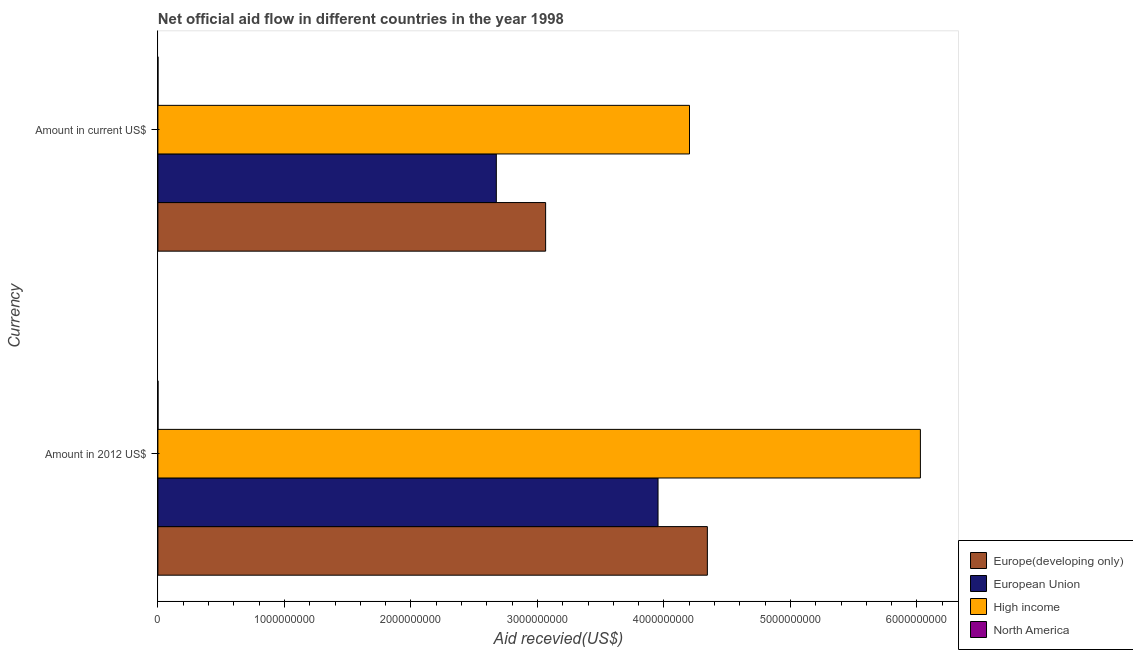How many groups of bars are there?
Make the answer very short. 2. Are the number of bars on each tick of the Y-axis equal?
Your response must be concise. Yes. How many bars are there on the 2nd tick from the top?
Ensure brevity in your answer.  4. How many bars are there on the 1st tick from the bottom?
Offer a very short reply. 4. What is the label of the 1st group of bars from the top?
Your answer should be very brief. Amount in current US$. What is the amount of aid received(expressed in 2012 us$) in North America?
Your answer should be compact. 7.40e+05. Across all countries, what is the maximum amount of aid received(expressed in us$)?
Provide a short and direct response. 4.20e+09. Across all countries, what is the minimum amount of aid received(expressed in 2012 us$)?
Your answer should be compact. 7.40e+05. In which country was the amount of aid received(expressed in us$) minimum?
Offer a very short reply. North America. What is the total amount of aid received(expressed in us$) in the graph?
Provide a short and direct response. 9.94e+09. What is the difference between the amount of aid received(expressed in 2012 us$) in North America and that in High income?
Provide a short and direct response. -6.03e+09. What is the difference between the amount of aid received(expressed in us$) in European Union and the amount of aid received(expressed in 2012 us$) in Europe(developing only)?
Make the answer very short. -1.67e+09. What is the average amount of aid received(expressed in us$) per country?
Provide a short and direct response. 2.49e+09. What is the difference between the amount of aid received(expressed in 2012 us$) and amount of aid received(expressed in us$) in European Union?
Provide a succinct answer. 1.28e+09. In how many countries, is the amount of aid received(expressed in us$) greater than 2200000000 US$?
Offer a very short reply. 3. What is the ratio of the amount of aid received(expressed in 2012 us$) in Europe(developing only) to that in European Union?
Make the answer very short. 1.1. Is the amount of aid received(expressed in 2012 us$) in High income less than that in Europe(developing only)?
Provide a short and direct response. No. In how many countries, is the amount of aid received(expressed in 2012 us$) greater than the average amount of aid received(expressed in 2012 us$) taken over all countries?
Your answer should be compact. 3. What does the 4th bar from the top in Amount in current US$ represents?
Your answer should be compact. Europe(developing only). What does the 3rd bar from the bottom in Amount in current US$ represents?
Make the answer very short. High income. Are all the bars in the graph horizontal?
Provide a succinct answer. Yes. How many countries are there in the graph?
Provide a succinct answer. 4. What is the difference between two consecutive major ticks on the X-axis?
Provide a succinct answer. 1.00e+09. Are the values on the major ticks of X-axis written in scientific E-notation?
Your answer should be compact. No. How are the legend labels stacked?
Ensure brevity in your answer.  Vertical. What is the title of the graph?
Make the answer very short. Net official aid flow in different countries in the year 1998. Does "Antigua and Barbuda" appear as one of the legend labels in the graph?
Your answer should be compact. No. What is the label or title of the X-axis?
Ensure brevity in your answer.  Aid recevied(US$). What is the label or title of the Y-axis?
Provide a succinct answer. Currency. What is the Aid recevied(US$) in Europe(developing only) in Amount in 2012 US$?
Give a very brief answer. 4.34e+09. What is the Aid recevied(US$) of European Union in Amount in 2012 US$?
Provide a succinct answer. 3.95e+09. What is the Aid recevied(US$) in High income in Amount in 2012 US$?
Provide a succinct answer. 6.03e+09. What is the Aid recevied(US$) in North America in Amount in 2012 US$?
Offer a terse response. 7.40e+05. What is the Aid recevied(US$) of Europe(developing only) in Amount in current US$?
Ensure brevity in your answer.  3.06e+09. What is the Aid recevied(US$) in European Union in Amount in current US$?
Keep it short and to the point. 2.68e+09. What is the Aid recevied(US$) in High income in Amount in current US$?
Your answer should be compact. 4.20e+09. What is the Aid recevied(US$) of North America in Amount in current US$?
Ensure brevity in your answer.  5.50e+05. Across all Currency, what is the maximum Aid recevied(US$) of Europe(developing only)?
Your answer should be compact. 4.34e+09. Across all Currency, what is the maximum Aid recevied(US$) of European Union?
Provide a succinct answer. 3.95e+09. Across all Currency, what is the maximum Aid recevied(US$) of High income?
Your answer should be very brief. 6.03e+09. Across all Currency, what is the maximum Aid recevied(US$) of North America?
Offer a terse response. 7.40e+05. Across all Currency, what is the minimum Aid recevied(US$) of Europe(developing only)?
Your response must be concise. 3.06e+09. Across all Currency, what is the minimum Aid recevied(US$) of European Union?
Ensure brevity in your answer.  2.68e+09. Across all Currency, what is the minimum Aid recevied(US$) of High income?
Keep it short and to the point. 4.20e+09. Across all Currency, what is the minimum Aid recevied(US$) in North America?
Keep it short and to the point. 5.50e+05. What is the total Aid recevied(US$) of Europe(developing only) in the graph?
Your answer should be very brief. 7.41e+09. What is the total Aid recevied(US$) in European Union in the graph?
Keep it short and to the point. 6.63e+09. What is the total Aid recevied(US$) of High income in the graph?
Offer a very short reply. 1.02e+1. What is the total Aid recevied(US$) of North America in the graph?
Provide a succinct answer. 1.29e+06. What is the difference between the Aid recevied(US$) of Europe(developing only) in Amount in 2012 US$ and that in Amount in current US$?
Your answer should be very brief. 1.28e+09. What is the difference between the Aid recevied(US$) in European Union in Amount in 2012 US$ and that in Amount in current US$?
Ensure brevity in your answer.  1.28e+09. What is the difference between the Aid recevied(US$) in High income in Amount in 2012 US$ and that in Amount in current US$?
Offer a very short reply. 1.83e+09. What is the difference between the Aid recevied(US$) in Europe(developing only) in Amount in 2012 US$ and the Aid recevied(US$) in European Union in Amount in current US$?
Your answer should be very brief. 1.67e+09. What is the difference between the Aid recevied(US$) in Europe(developing only) in Amount in 2012 US$ and the Aid recevied(US$) in High income in Amount in current US$?
Ensure brevity in your answer.  1.41e+08. What is the difference between the Aid recevied(US$) of Europe(developing only) in Amount in 2012 US$ and the Aid recevied(US$) of North America in Amount in current US$?
Make the answer very short. 4.34e+09. What is the difference between the Aid recevied(US$) of European Union in Amount in 2012 US$ and the Aid recevied(US$) of High income in Amount in current US$?
Offer a terse response. -2.49e+08. What is the difference between the Aid recevied(US$) of European Union in Amount in 2012 US$ and the Aid recevied(US$) of North America in Amount in current US$?
Offer a terse response. 3.95e+09. What is the difference between the Aid recevied(US$) in High income in Amount in 2012 US$ and the Aid recevied(US$) in North America in Amount in current US$?
Ensure brevity in your answer.  6.03e+09. What is the average Aid recevied(US$) of Europe(developing only) per Currency?
Ensure brevity in your answer.  3.70e+09. What is the average Aid recevied(US$) in European Union per Currency?
Offer a terse response. 3.31e+09. What is the average Aid recevied(US$) of High income per Currency?
Ensure brevity in your answer.  5.11e+09. What is the average Aid recevied(US$) in North America per Currency?
Offer a very short reply. 6.45e+05. What is the difference between the Aid recevied(US$) in Europe(developing only) and Aid recevied(US$) in European Union in Amount in 2012 US$?
Offer a very short reply. 3.90e+08. What is the difference between the Aid recevied(US$) in Europe(developing only) and Aid recevied(US$) in High income in Amount in 2012 US$?
Provide a succinct answer. -1.68e+09. What is the difference between the Aid recevied(US$) of Europe(developing only) and Aid recevied(US$) of North America in Amount in 2012 US$?
Keep it short and to the point. 4.34e+09. What is the difference between the Aid recevied(US$) in European Union and Aid recevied(US$) in High income in Amount in 2012 US$?
Keep it short and to the point. -2.07e+09. What is the difference between the Aid recevied(US$) in European Union and Aid recevied(US$) in North America in Amount in 2012 US$?
Keep it short and to the point. 3.95e+09. What is the difference between the Aid recevied(US$) in High income and Aid recevied(US$) in North America in Amount in 2012 US$?
Give a very brief answer. 6.03e+09. What is the difference between the Aid recevied(US$) of Europe(developing only) and Aid recevied(US$) of European Union in Amount in current US$?
Offer a very short reply. 3.90e+08. What is the difference between the Aid recevied(US$) of Europe(developing only) and Aid recevied(US$) of High income in Amount in current US$?
Provide a short and direct response. -1.14e+09. What is the difference between the Aid recevied(US$) of Europe(developing only) and Aid recevied(US$) of North America in Amount in current US$?
Provide a short and direct response. 3.06e+09. What is the difference between the Aid recevied(US$) of European Union and Aid recevied(US$) of High income in Amount in current US$?
Your answer should be compact. -1.53e+09. What is the difference between the Aid recevied(US$) in European Union and Aid recevied(US$) in North America in Amount in current US$?
Your answer should be very brief. 2.67e+09. What is the difference between the Aid recevied(US$) in High income and Aid recevied(US$) in North America in Amount in current US$?
Provide a succinct answer. 4.20e+09. What is the ratio of the Aid recevied(US$) of Europe(developing only) in Amount in 2012 US$ to that in Amount in current US$?
Provide a short and direct response. 1.42. What is the ratio of the Aid recevied(US$) in European Union in Amount in 2012 US$ to that in Amount in current US$?
Your response must be concise. 1.48. What is the ratio of the Aid recevied(US$) in High income in Amount in 2012 US$ to that in Amount in current US$?
Your response must be concise. 1.43. What is the ratio of the Aid recevied(US$) in North America in Amount in 2012 US$ to that in Amount in current US$?
Keep it short and to the point. 1.35. What is the difference between the highest and the second highest Aid recevied(US$) in Europe(developing only)?
Your answer should be compact. 1.28e+09. What is the difference between the highest and the second highest Aid recevied(US$) of European Union?
Your answer should be very brief. 1.28e+09. What is the difference between the highest and the second highest Aid recevied(US$) in High income?
Your answer should be compact. 1.83e+09. What is the difference between the highest and the lowest Aid recevied(US$) in Europe(developing only)?
Keep it short and to the point. 1.28e+09. What is the difference between the highest and the lowest Aid recevied(US$) of European Union?
Give a very brief answer. 1.28e+09. What is the difference between the highest and the lowest Aid recevied(US$) of High income?
Your answer should be very brief. 1.83e+09. What is the difference between the highest and the lowest Aid recevied(US$) of North America?
Your answer should be very brief. 1.90e+05. 